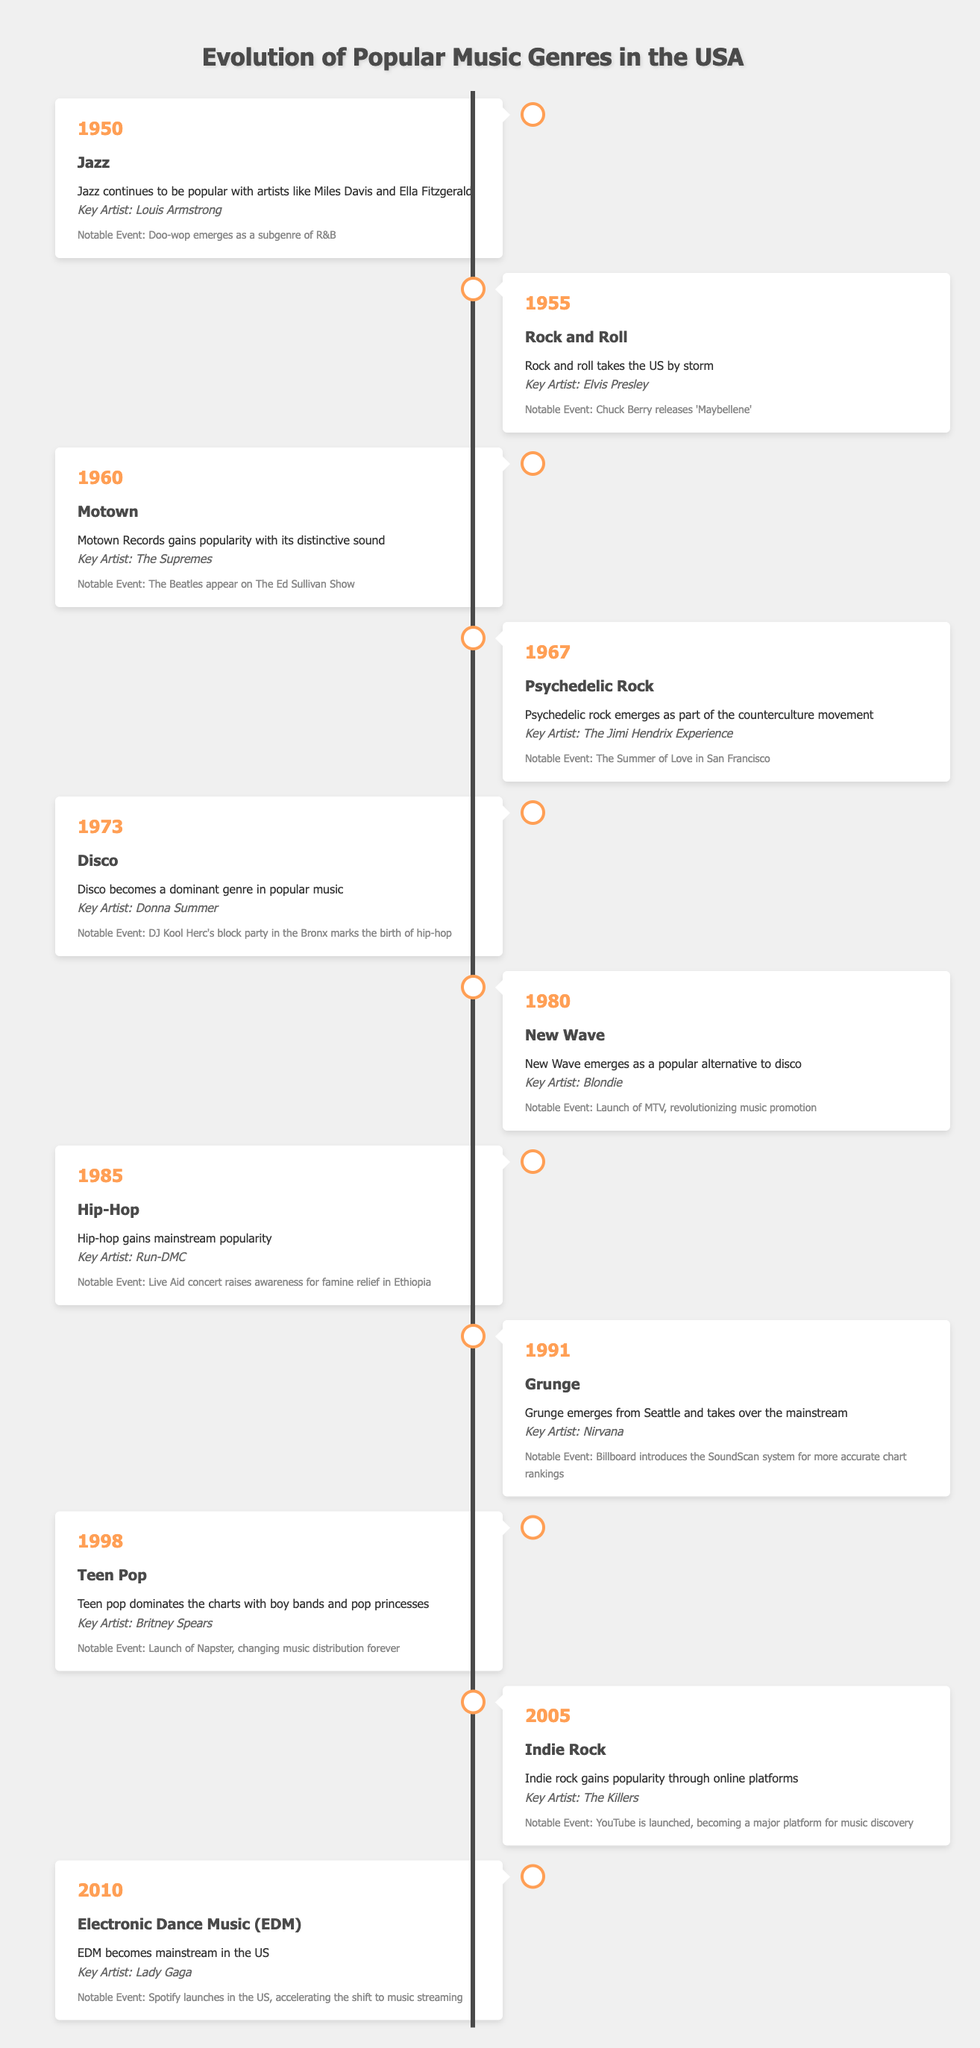What was the dominant genre of popular music in 1973? According to the table, the genre listed for the year 1973 is Disco.
Answer: Disco Which artist is associated with the genre of Hip-Hop in 1985? The table indicates that Run-DMC is the key artist for the genre Hip-Hop in the year 1985.
Answer: Run-DMC In what year did Teen Pop dominate the charts? The table shows that Teen Pop is noted for the year 1998.
Answer: 1998 Was Jazz still popular in 1950? Yes, the description for the year 1950 mentions that Jazz continues to be popular with notable artists like Miles Davis and Ella Fitzgerald.
Answer: Yes What notable event occurred in 1991 and what genre was emerging at that time? The table shows that in 1991, Grunge was emerging, and the notable event was the introduction of the SoundScan system by Billboard for chart rankings.
Answer: Grunge; SoundScan introduction Which genre had a key artist of Lady Gaga and in what year did it become mainstream? The table states that Electronic Dance Music (EDM) became mainstream in 2010, with Lady Gaga as the key artist.
Answer: 2010; EDM List all genres mentioned in the timeline between 1960 and 1980. The genres mentioned in the timeline from the year 1960 to 1980 are Motown (1960), Psychedelic Rock (1967), Disco (1973), and New Wave (1980).
Answer: Motown, Psychedelic Rock, Disco, New Wave What was the notable event in 2005, and how did it impact music discovery? The notable event in 2005 was the launch of YouTube, which became a major platform for music discovery. This fundamentally changed how people accessed and discovered new music.
Answer: YouTube launched; it changed music discovery How many years passed between the emergence of Hip-Hop in 1985 and the rise of Teen Pop in 1998? To determine the number of years between the two genres, we subtract 1985 from 1998, which equals 13 years.
Answer: 13 years 